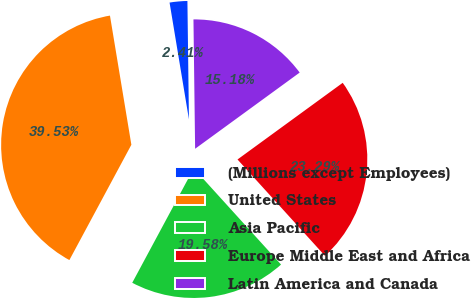<chart> <loc_0><loc_0><loc_500><loc_500><pie_chart><fcel>(Millions except Employees)<fcel>United States<fcel>Asia Pacific<fcel>Europe Middle East and Africa<fcel>Latin America and Canada<nl><fcel>2.41%<fcel>39.53%<fcel>19.58%<fcel>23.29%<fcel>15.18%<nl></chart> 